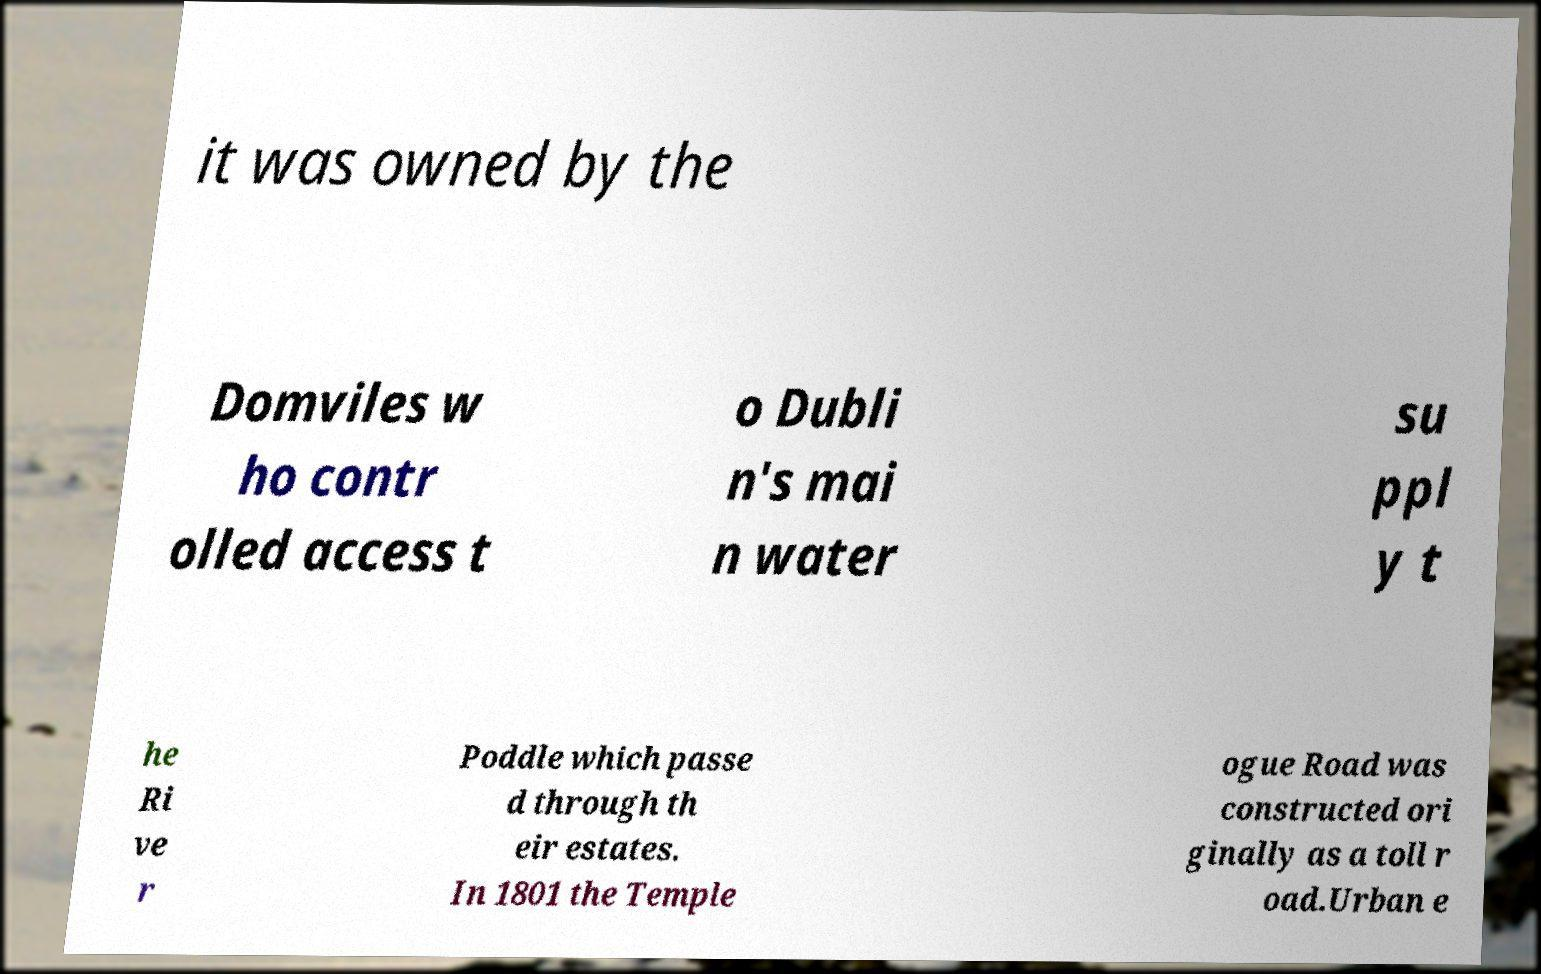Can you accurately transcribe the text from the provided image for me? it was owned by the Domviles w ho contr olled access t o Dubli n's mai n water su ppl y t he Ri ve r Poddle which passe d through th eir estates. In 1801 the Temple ogue Road was constructed ori ginally as a toll r oad.Urban e 